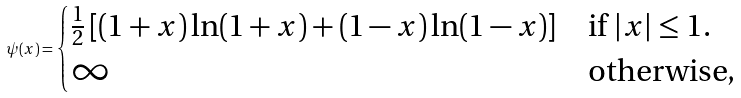<formula> <loc_0><loc_0><loc_500><loc_500>\psi ( x ) = \begin{cases} \frac { 1 } { 2 } \left [ ( 1 + x ) \ln ( 1 + x ) + ( 1 - x ) \ln ( 1 - x ) \right ] & \text {if $|x| \leq 1$.} \\ \infty & \text {otherwise,} \end{cases}</formula> 